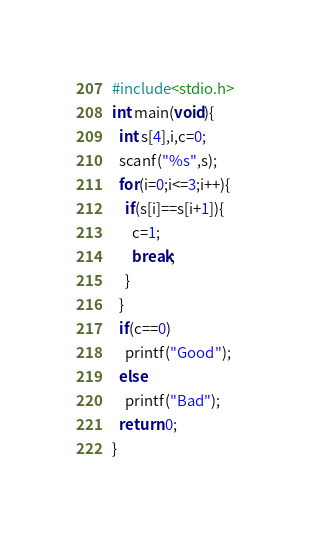Convert code to text. <code><loc_0><loc_0><loc_500><loc_500><_C_>#include<stdio.h>
int main(void){
  int s[4],i,c=0;
  scanf("%s",s);
  for(i=0;i<=3;i++){
    if(s[i]==s[i+1]){
      c=1;
      break;
    }
  }
  if(c==0)
    printf("Good");
  else
    printf("Bad");
  return 0;
}</code> 